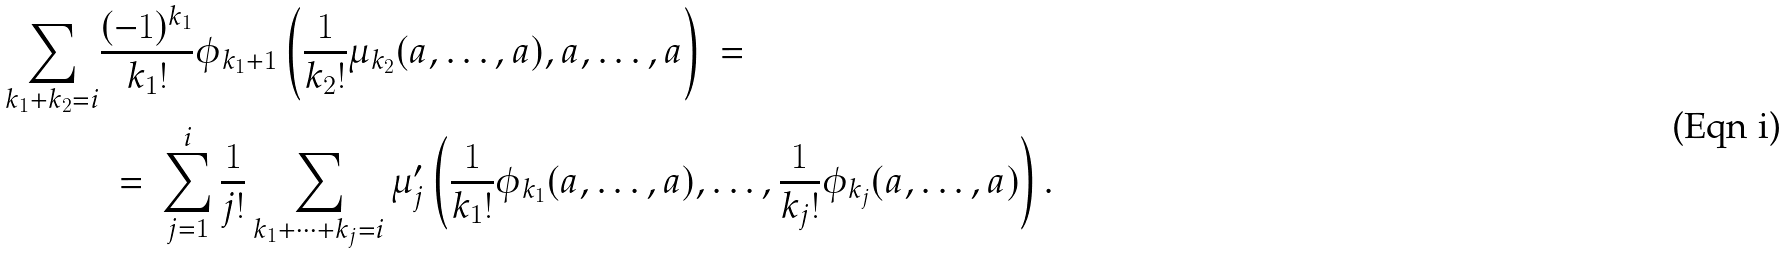<formula> <loc_0><loc_0><loc_500><loc_500>\sum _ { k _ { 1 } + k _ { 2 } = i } & \frac { ( - 1 ) ^ { k _ { 1 } } } { k _ { 1 } ! } \phi _ { k _ { 1 } + 1 } \left ( \frac { 1 } { k _ { 2 } ! } \mu _ { k _ { 2 } } ( a , \dots , a ) , a , \dots , a \right ) \ = \\ & \ = \ \sum _ { j = 1 } ^ { i } \frac { 1 } { j ! } \sum _ { k _ { 1 } + \cdots + k _ { j } = i } \mu ^ { \prime } _ { j } \left ( \frac { 1 } { k _ { 1 } ! } \phi _ { k _ { 1 } } ( a , \dots , a ) , \dots , \frac { 1 } { k _ { j } ! } \phi _ { k _ { j } } ( a , \dots , a ) \right ) .</formula> 